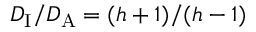<formula> <loc_0><loc_0><loc_500><loc_500>D _ { I } / D _ { A } = ( h + 1 ) / ( h - 1 )</formula> 